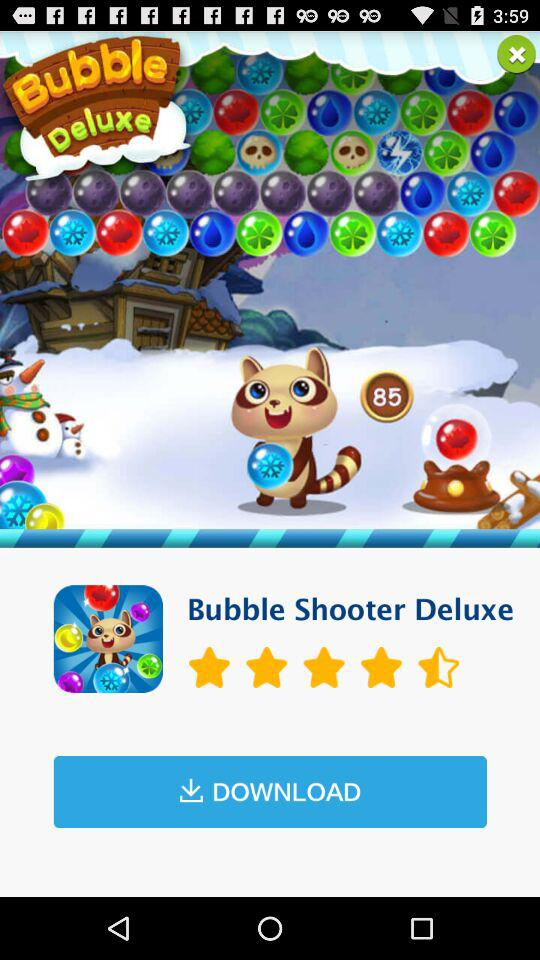What is the star rating of the application? The star rating is 4.5. 